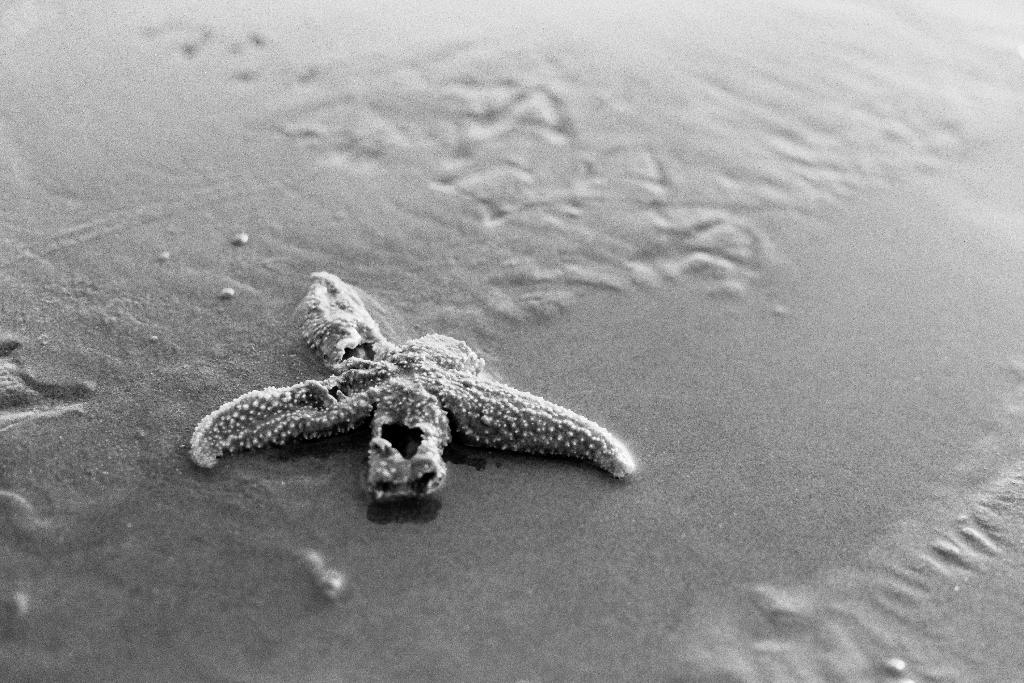What type of environment is depicted in the image? The image shows a combination of water and sand, suggesting a beach or coastal setting. What can be found in the water in the image? There is an aquatic animal in the water in the image. Can you describe the texture of the sand in the image? The sand appears to be fine and smooth, typical of a beach. What type of milk is being served in the downtown area in the image? There is no milk or downtown area present in the image; it features water, sand, and an aquatic animal. Can you describe the mountain range visible in the background of the image? There is no mountain range visible in the image; it features water, sand, and an aquatic animal. 